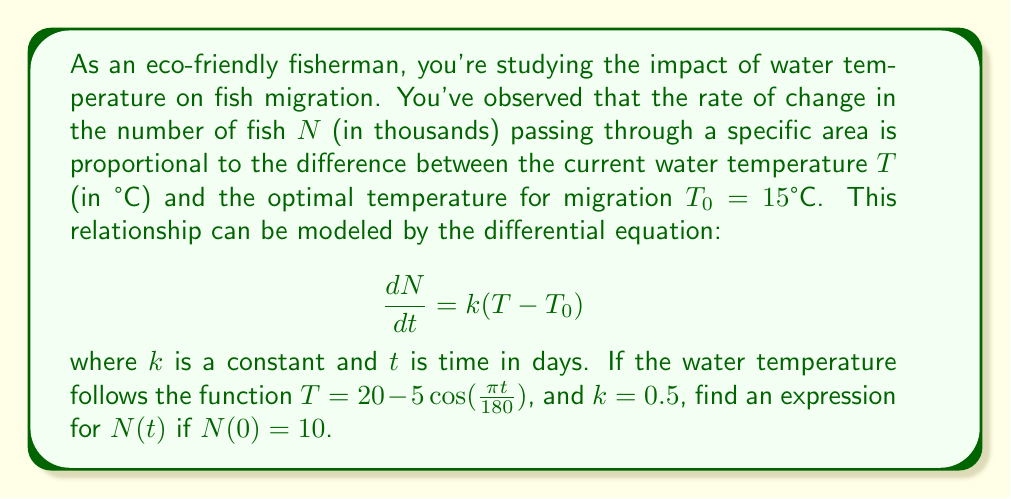Teach me how to tackle this problem. To solve this first-order linear differential equation, we'll follow these steps:

1) First, let's substitute the given temperature function into our differential equation:

   $$\frac{dN}{dt} = 0.5[(20 - 5\cos(\frac{\pi t}{180})) - 15]$$
   $$\frac{dN}{dt} = 0.5[5 - 5\cos(\frac{\pi t}{180})]$$
   $$\frac{dN}{dt} = 2.5 - 2.5\cos(\frac{\pi t}{180})$$

2) To solve this, we need to integrate both sides:

   $$\int \frac{dN}{dt} dt = \int (2.5 - 2.5\cos(\frac{\pi t}{180})) dt$$

3) Integrating the right side:

   $$N = 2.5t + 2.5 \cdot \frac{180}{\pi} \sin(\frac{\pi t}{180}) + C$$

4) To find the constant of integration $C$, we use the initial condition $N(0) = 10$:

   $$10 = 2.5(0) + 2.5 \cdot \frac{180}{\pi} \sin(0) + C$$
   $$10 = C$$

5) Therefore, our final solution is:

   $$N(t) = 2.5t + 2.5 \cdot \frac{180}{\pi} \sin(\frac{\pi t}{180}) + 10$$

This equation represents the number of fish (in thousands) passing through the area as a function of time (in days).
Answer: $$N(t) = 2.5t + 450\pi^{-1} \sin(\frac{\pi t}{180}) + 10$$ 